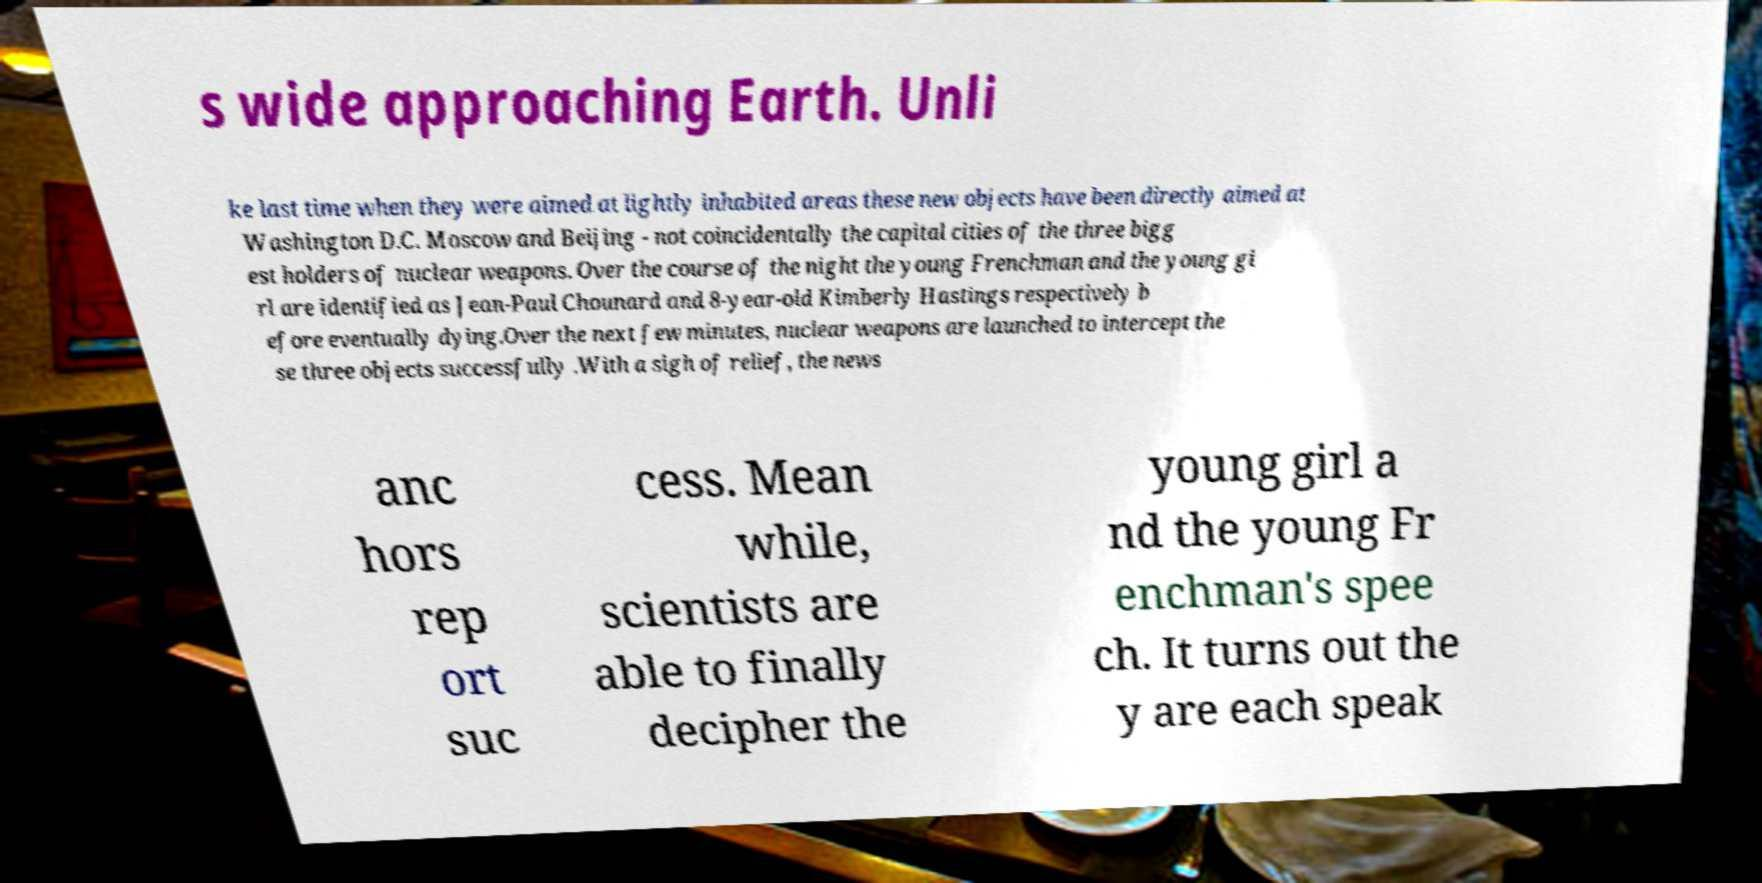What messages or text are displayed in this image? I need them in a readable, typed format. s wide approaching Earth. Unli ke last time when they were aimed at lightly inhabited areas these new objects have been directly aimed at Washington D.C. Moscow and Beijing - not coincidentally the capital cities of the three bigg est holders of nuclear weapons. Over the course of the night the young Frenchman and the young gi rl are identified as Jean-Paul Chounard and 8-year-old Kimberly Hastings respectively b efore eventually dying.Over the next few minutes, nuclear weapons are launched to intercept the se three objects successfully .With a sigh of relief, the news anc hors rep ort suc cess. Mean while, scientists are able to finally decipher the young girl a nd the young Fr enchman's spee ch. It turns out the y are each speak 